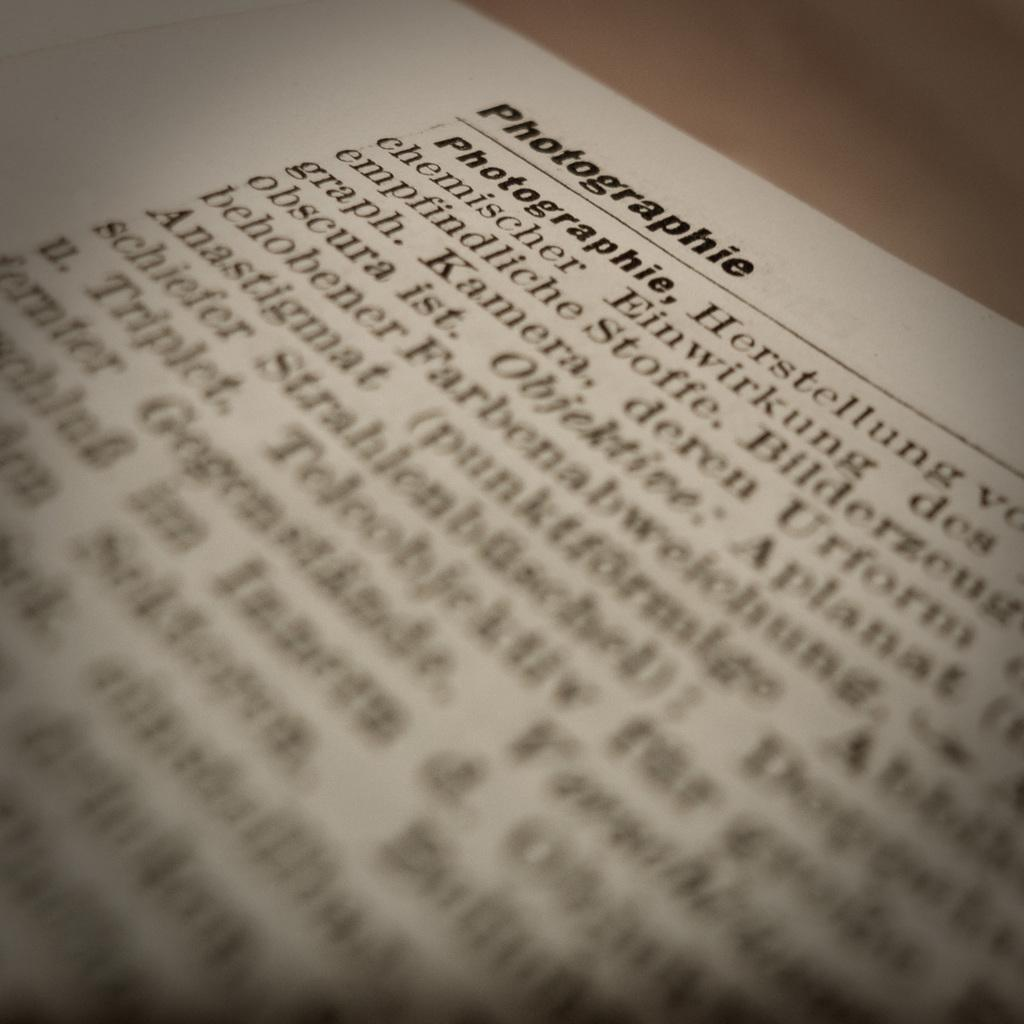<image>
Offer a succinct explanation of the picture presented. A book is open to a section about Photographie. 